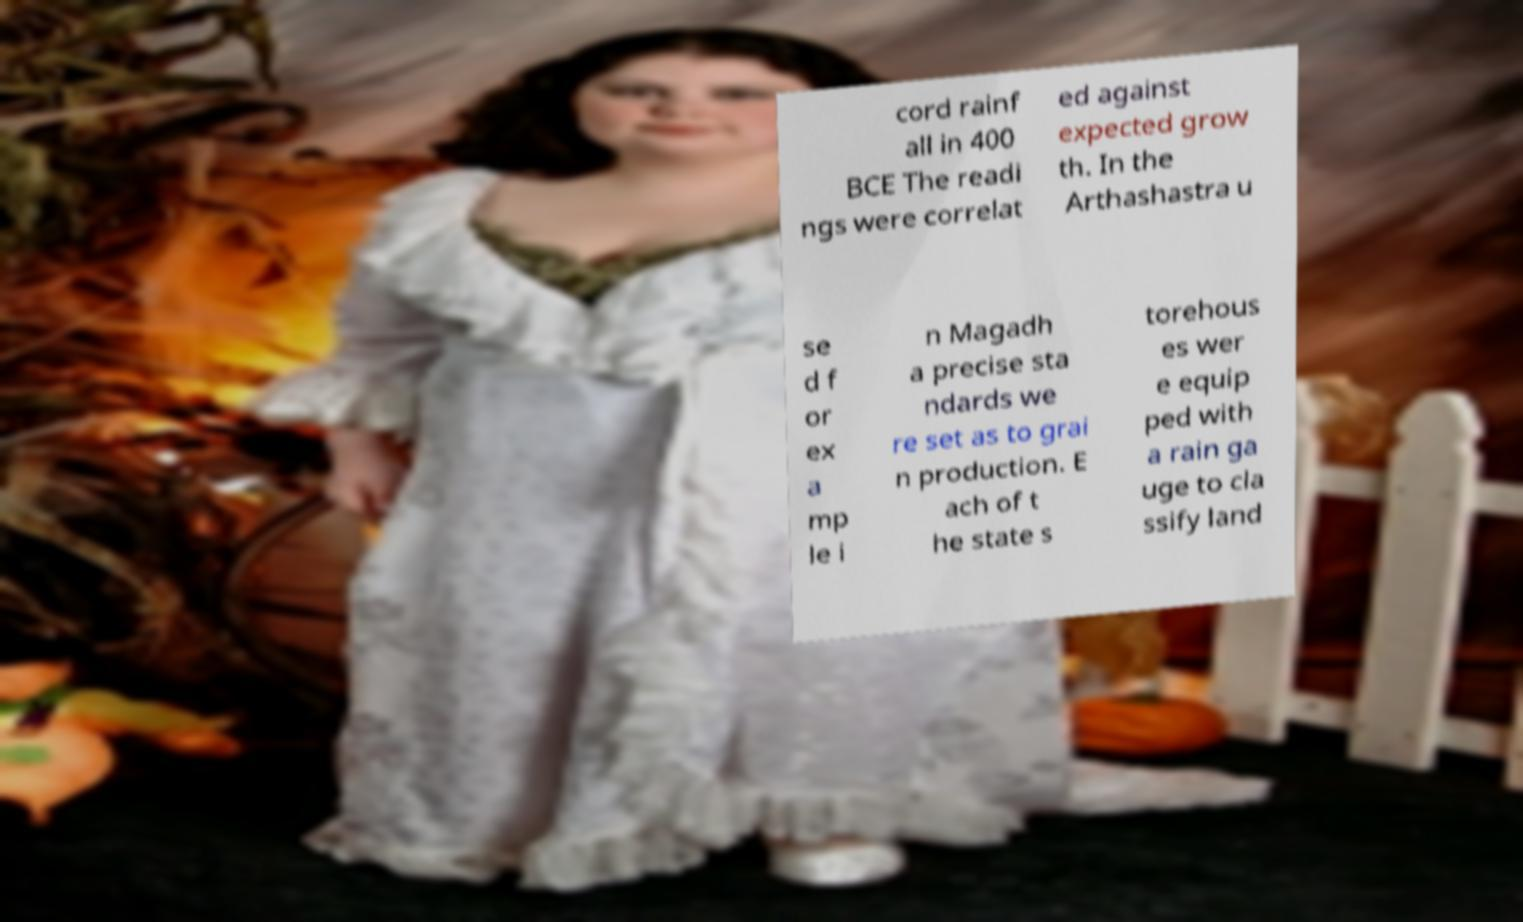Could you extract and type out the text from this image? cord rainf all in 400 BCE The readi ngs were correlat ed against expected grow th. In the Arthashastra u se d f or ex a mp le i n Magadh a precise sta ndards we re set as to grai n production. E ach of t he state s torehous es wer e equip ped with a rain ga uge to cla ssify land 